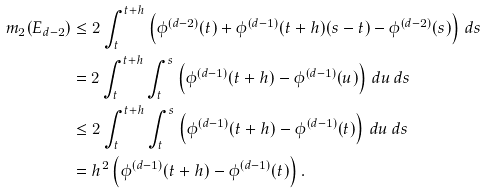<formula> <loc_0><loc_0><loc_500><loc_500>m _ { 2 } ( E _ { d - 2 } ) & \leq 2 \int \nolimits _ { t } ^ { t + h } \left ( \phi ^ { ( d - 2 ) } ( t ) + \phi ^ { ( d - 1 ) } ( t + h ) ( s - t ) - \phi ^ { ( d - 2 ) } ( s ) \right ) \, d s \\ & = 2 \int \nolimits _ { t } ^ { t + h } \int \nolimits _ { t } ^ { s } \left ( \phi ^ { ( d - 1 ) } ( t + h ) - \phi ^ { ( d - 1 ) } ( u ) \right ) \, d u \, d s \\ & \leq 2 \int _ { t } ^ { t + h } \int \nolimits _ { t } ^ { s } \left ( \phi ^ { ( d - 1 ) } ( t + h ) - \phi ^ { ( d - 1 ) } ( t ) \right ) \, d u \, d s \\ & = h ^ { 2 } \left ( \phi ^ { ( d - 1 ) } ( t + h ) - \phi ^ { ( d - 1 ) } ( t ) \right ) .</formula> 